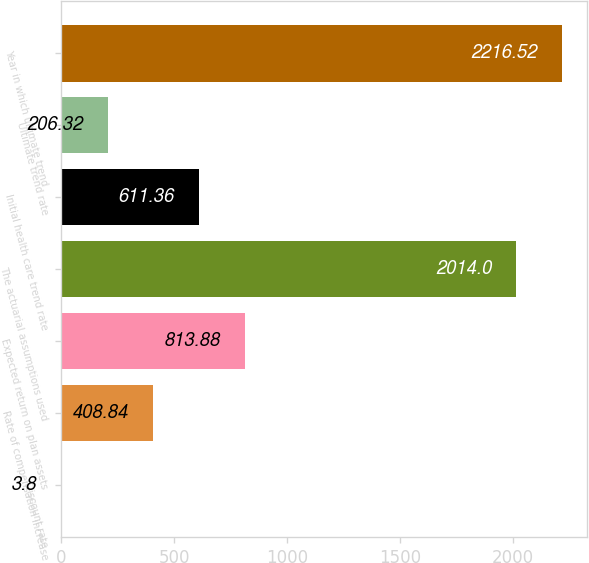<chart> <loc_0><loc_0><loc_500><loc_500><bar_chart><fcel>Discount rate<fcel>Rate of compensation increase<fcel>Expected return on plan assets<fcel>The actuarial assumptions used<fcel>Initial health care trend rate<fcel>Ultimate trend rate<fcel>Year in which ultimate trend<nl><fcel>3.8<fcel>408.84<fcel>813.88<fcel>2014<fcel>611.36<fcel>206.32<fcel>2216.52<nl></chart> 